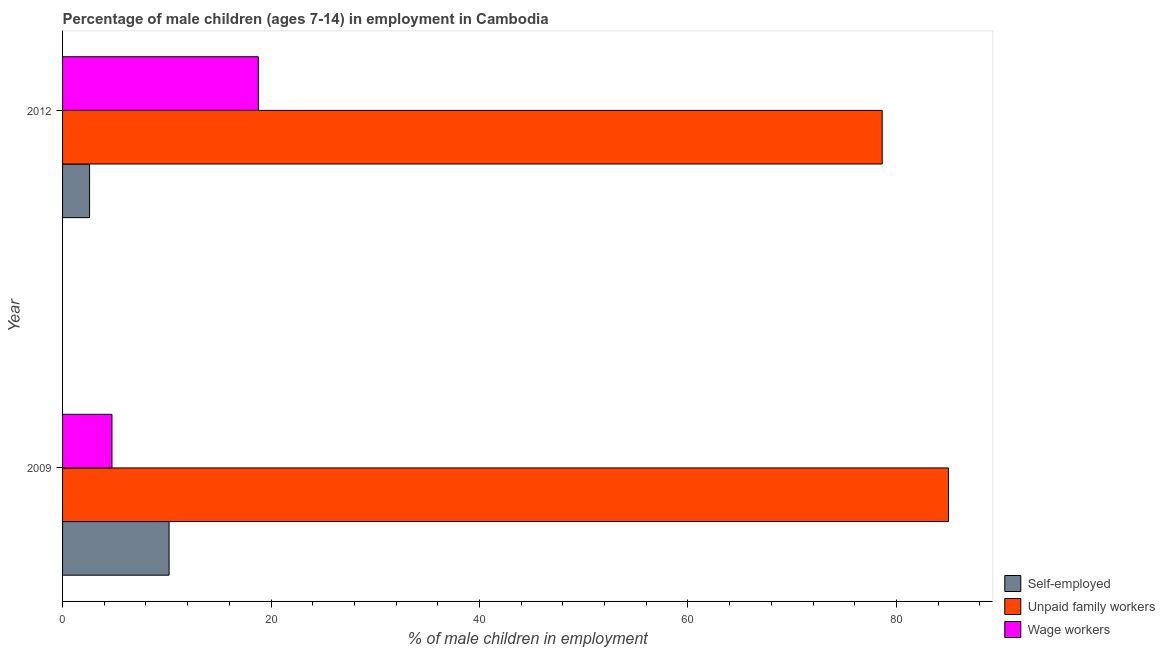Are the number of bars per tick equal to the number of legend labels?
Your response must be concise. Yes. How many bars are there on the 2nd tick from the bottom?
Keep it short and to the point. 3. What is the label of the 2nd group of bars from the top?
Offer a very short reply. 2009. What is the percentage of self employed children in 2009?
Offer a very short reply. 10.22. Across all years, what is the maximum percentage of children employed as wage workers?
Offer a terse response. 18.78. Across all years, what is the minimum percentage of children employed as unpaid family workers?
Your response must be concise. 78.63. In which year was the percentage of children employed as wage workers maximum?
Provide a short and direct response. 2012. What is the total percentage of self employed children in the graph?
Ensure brevity in your answer.  12.81. What is the difference between the percentage of children employed as wage workers in 2009 and that in 2012?
Ensure brevity in your answer.  -14.04. What is the difference between the percentage of self employed children in 2009 and the percentage of children employed as wage workers in 2012?
Your answer should be very brief. -8.56. What is the average percentage of self employed children per year?
Give a very brief answer. 6.41. In the year 2012, what is the difference between the percentage of self employed children and percentage of children employed as unpaid family workers?
Provide a succinct answer. -76.04. What is the ratio of the percentage of self employed children in 2009 to that in 2012?
Provide a succinct answer. 3.95. Is the difference between the percentage of self employed children in 2009 and 2012 greater than the difference between the percentage of children employed as wage workers in 2009 and 2012?
Keep it short and to the point. Yes. In how many years, is the percentage of children employed as wage workers greater than the average percentage of children employed as wage workers taken over all years?
Make the answer very short. 1. What does the 3rd bar from the top in 2009 represents?
Your answer should be compact. Self-employed. What does the 3rd bar from the bottom in 2012 represents?
Your answer should be compact. Wage workers. Is it the case that in every year, the sum of the percentage of self employed children and percentage of children employed as unpaid family workers is greater than the percentage of children employed as wage workers?
Your answer should be very brief. Yes. Does the graph contain any zero values?
Ensure brevity in your answer.  No. Does the graph contain grids?
Make the answer very short. No. How are the legend labels stacked?
Keep it short and to the point. Vertical. What is the title of the graph?
Ensure brevity in your answer.  Percentage of male children (ages 7-14) in employment in Cambodia. What is the label or title of the X-axis?
Give a very brief answer. % of male children in employment. What is the % of male children in employment of Self-employed in 2009?
Provide a succinct answer. 10.22. What is the % of male children in employment in Unpaid family workers in 2009?
Your answer should be compact. 84.99. What is the % of male children in employment of Wage workers in 2009?
Offer a terse response. 4.74. What is the % of male children in employment in Self-employed in 2012?
Give a very brief answer. 2.59. What is the % of male children in employment of Unpaid family workers in 2012?
Your answer should be compact. 78.63. What is the % of male children in employment in Wage workers in 2012?
Provide a succinct answer. 18.78. Across all years, what is the maximum % of male children in employment of Self-employed?
Your answer should be very brief. 10.22. Across all years, what is the maximum % of male children in employment of Unpaid family workers?
Keep it short and to the point. 84.99. Across all years, what is the maximum % of male children in employment in Wage workers?
Provide a succinct answer. 18.78. Across all years, what is the minimum % of male children in employment in Self-employed?
Make the answer very short. 2.59. Across all years, what is the minimum % of male children in employment in Unpaid family workers?
Ensure brevity in your answer.  78.63. Across all years, what is the minimum % of male children in employment of Wage workers?
Your response must be concise. 4.74. What is the total % of male children in employment of Self-employed in the graph?
Your answer should be compact. 12.81. What is the total % of male children in employment of Unpaid family workers in the graph?
Keep it short and to the point. 163.62. What is the total % of male children in employment in Wage workers in the graph?
Offer a terse response. 23.52. What is the difference between the % of male children in employment in Self-employed in 2009 and that in 2012?
Provide a short and direct response. 7.63. What is the difference between the % of male children in employment of Unpaid family workers in 2009 and that in 2012?
Your answer should be compact. 6.36. What is the difference between the % of male children in employment of Wage workers in 2009 and that in 2012?
Your answer should be compact. -14.04. What is the difference between the % of male children in employment of Self-employed in 2009 and the % of male children in employment of Unpaid family workers in 2012?
Provide a succinct answer. -68.41. What is the difference between the % of male children in employment in Self-employed in 2009 and the % of male children in employment in Wage workers in 2012?
Give a very brief answer. -8.56. What is the difference between the % of male children in employment in Unpaid family workers in 2009 and the % of male children in employment in Wage workers in 2012?
Give a very brief answer. 66.21. What is the average % of male children in employment in Self-employed per year?
Your answer should be very brief. 6.41. What is the average % of male children in employment in Unpaid family workers per year?
Give a very brief answer. 81.81. What is the average % of male children in employment in Wage workers per year?
Offer a terse response. 11.76. In the year 2009, what is the difference between the % of male children in employment of Self-employed and % of male children in employment of Unpaid family workers?
Your answer should be compact. -74.77. In the year 2009, what is the difference between the % of male children in employment of Self-employed and % of male children in employment of Wage workers?
Give a very brief answer. 5.48. In the year 2009, what is the difference between the % of male children in employment in Unpaid family workers and % of male children in employment in Wage workers?
Keep it short and to the point. 80.25. In the year 2012, what is the difference between the % of male children in employment of Self-employed and % of male children in employment of Unpaid family workers?
Offer a very short reply. -76.04. In the year 2012, what is the difference between the % of male children in employment in Self-employed and % of male children in employment in Wage workers?
Give a very brief answer. -16.19. In the year 2012, what is the difference between the % of male children in employment of Unpaid family workers and % of male children in employment of Wage workers?
Offer a terse response. 59.85. What is the ratio of the % of male children in employment in Self-employed in 2009 to that in 2012?
Your answer should be very brief. 3.95. What is the ratio of the % of male children in employment of Unpaid family workers in 2009 to that in 2012?
Keep it short and to the point. 1.08. What is the ratio of the % of male children in employment of Wage workers in 2009 to that in 2012?
Keep it short and to the point. 0.25. What is the difference between the highest and the second highest % of male children in employment in Self-employed?
Give a very brief answer. 7.63. What is the difference between the highest and the second highest % of male children in employment in Unpaid family workers?
Offer a very short reply. 6.36. What is the difference between the highest and the second highest % of male children in employment in Wage workers?
Keep it short and to the point. 14.04. What is the difference between the highest and the lowest % of male children in employment in Self-employed?
Provide a succinct answer. 7.63. What is the difference between the highest and the lowest % of male children in employment of Unpaid family workers?
Your response must be concise. 6.36. What is the difference between the highest and the lowest % of male children in employment in Wage workers?
Make the answer very short. 14.04. 